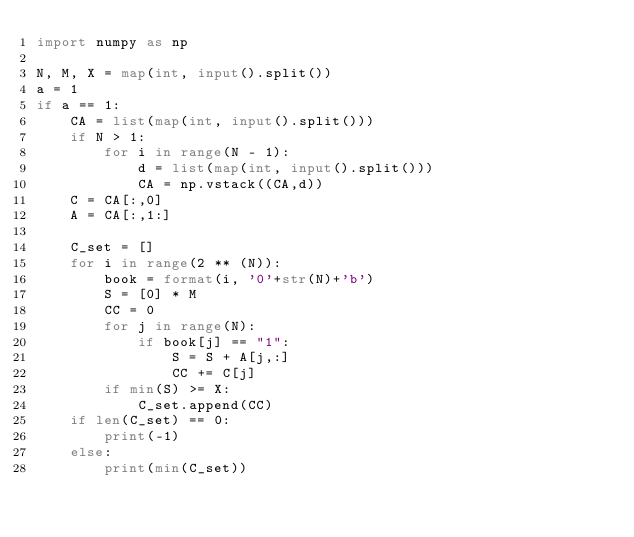Convert code to text. <code><loc_0><loc_0><loc_500><loc_500><_Python_>import numpy as np

N, M, X = map(int, input().split())
a = 1
if a == 1:
    CA = list(map(int, input().split()))
    if N > 1:
        for i in range(N - 1):
            d = list(map(int, input().split()))
            CA = np.vstack((CA,d))
    C = CA[:,0]
    A = CA[:,1:]

    C_set = []
    for i in range(2 ** (N)):
        book = format(i, '0'+str(N)+'b')
        S = [0] * M
        CC = 0
        for j in range(N):
            if book[j] == "1":
                S = S + A[j,:]
                CC += C[j]
        if min(S) >= X:
            C_set.append(CC)
    if len(C_set) == 0:
        print(-1)
    else:
        print(min(C_set))
</code> 